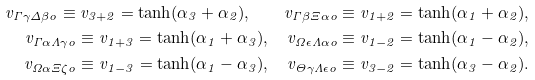Convert formula to latex. <formula><loc_0><loc_0><loc_500><loc_500>v _ { \Gamma \gamma \Delta \beta o } \equiv v _ { 3 + 2 } = \tanh ( \alpha _ { 3 } + \alpha _ { 2 } ) , \quad v _ { \Gamma \beta \Xi \alpha o } \equiv v _ { 1 + 2 } = \tanh ( \alpha _ { 1 } + \alpha _ { 2 } ) , \\ v _ { \Gamma \alpha \Lambda \gamma o } \equiv v _ { 1 + 3 } = \tanh ( \alpha _ { 1 } + \alpha _ { 3 } ) , \quad v _ { \Omega \epsilon \Lambda \alpha o } \equiv v _ { 1 - 2 } = \tanh ( \alpha _ { 1 } - \alpha _ { 2 } ) , \\ v _ { \Omega \alpha \Xi \zeta o } \equiv v _ { 1 - 3 } = \tanh ( \alpha _ { 1 } - \alpha _ { 3 } ) , \quad v _ { \Theta \gamma \Lambda \epsilon o } \equiv v _ { 3 - 2 } = \tanh ( \alpha _ { 3 } - \alpha _ { 2 } ) .</formula> 